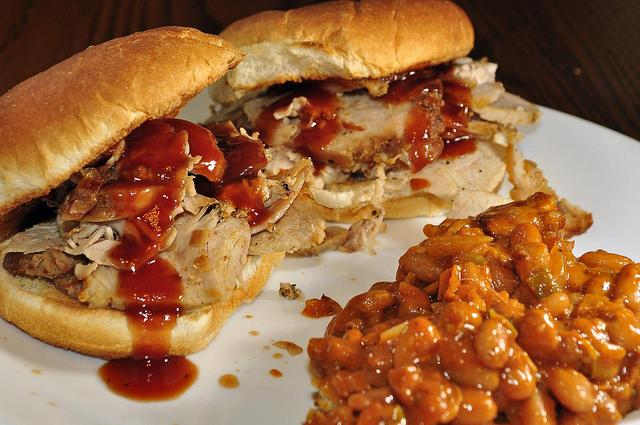What is the original color of the baked beans in the dish? Please explain your reasoning. white. The original color cannot be gleaned from the image, but the beans are a brownish color now and likely started as a slightly lighter shade. 